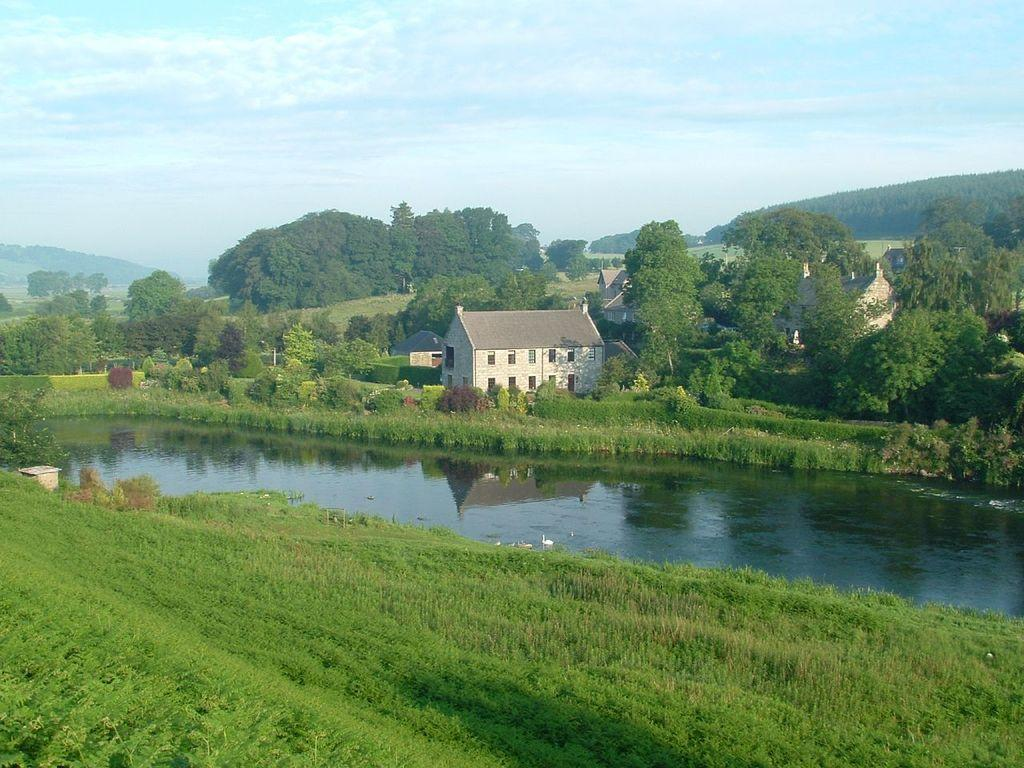What type of vegetation is present in the image? There is grass in the image. What natural feature can be seen in the image? There is water in the image. What type of structure is visible in the image? There is a house in the image. What type of plant life is present in the image? There is a bunch of trees in the image. What geographical feature is visible in the image? There are mountains in the image. What is visible at the top of the image? The sky is visible at the top of the image. Can you tell me how many zippers are visible in the image? There are no zippers present in the image. Is there any quicksand visible in the image? There is no quicksand present in the image. 